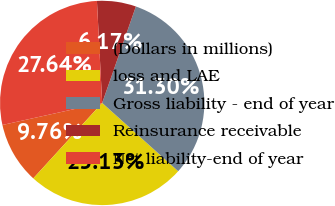<chart> <loc_0><loc_0><loc_500><loc_500><pie_chart><fcel>(Dollars in millions)<fcel>loss and LAE<fcel>Gross liability - end of year<fcel>Reinsurance receivable<fcel>Net liability-end of year<nl><fcel>9.76%<fcel>25.13%<fcel>31.3%<fcel>6.17%<fcel>27.64%<nl></chart> 